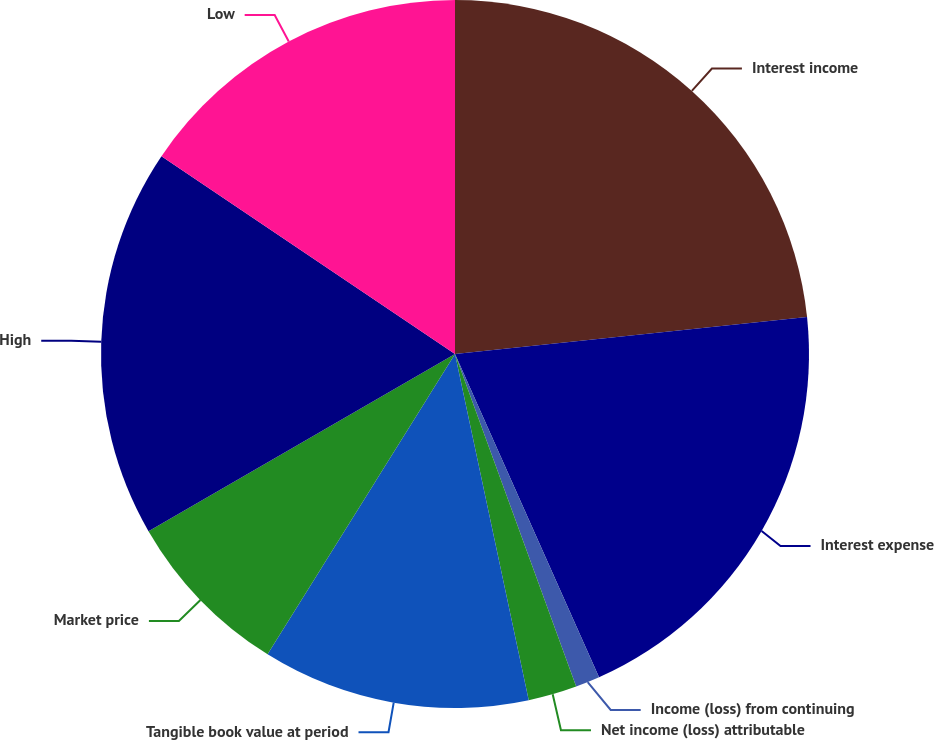Convert chart to OTSL. <chart><loc_0><loc_0><loc_500><loc_500><pie_chart><fcel>Interest income<fcel>Interest expense<fcel>Income (loss) from continuing<fcel>Net income (loss) attributable<fcel>Tangible book value at period<fcel>Market price<fcel>High<fcel>Low<nl><fcel>23.33%<fcel>20.0%<fcel>1.11%<fcel>2.22%<fcel>12.22%<fcel>7.78%<fcel>17.78%<fcel>15.56%<nl></chart> 